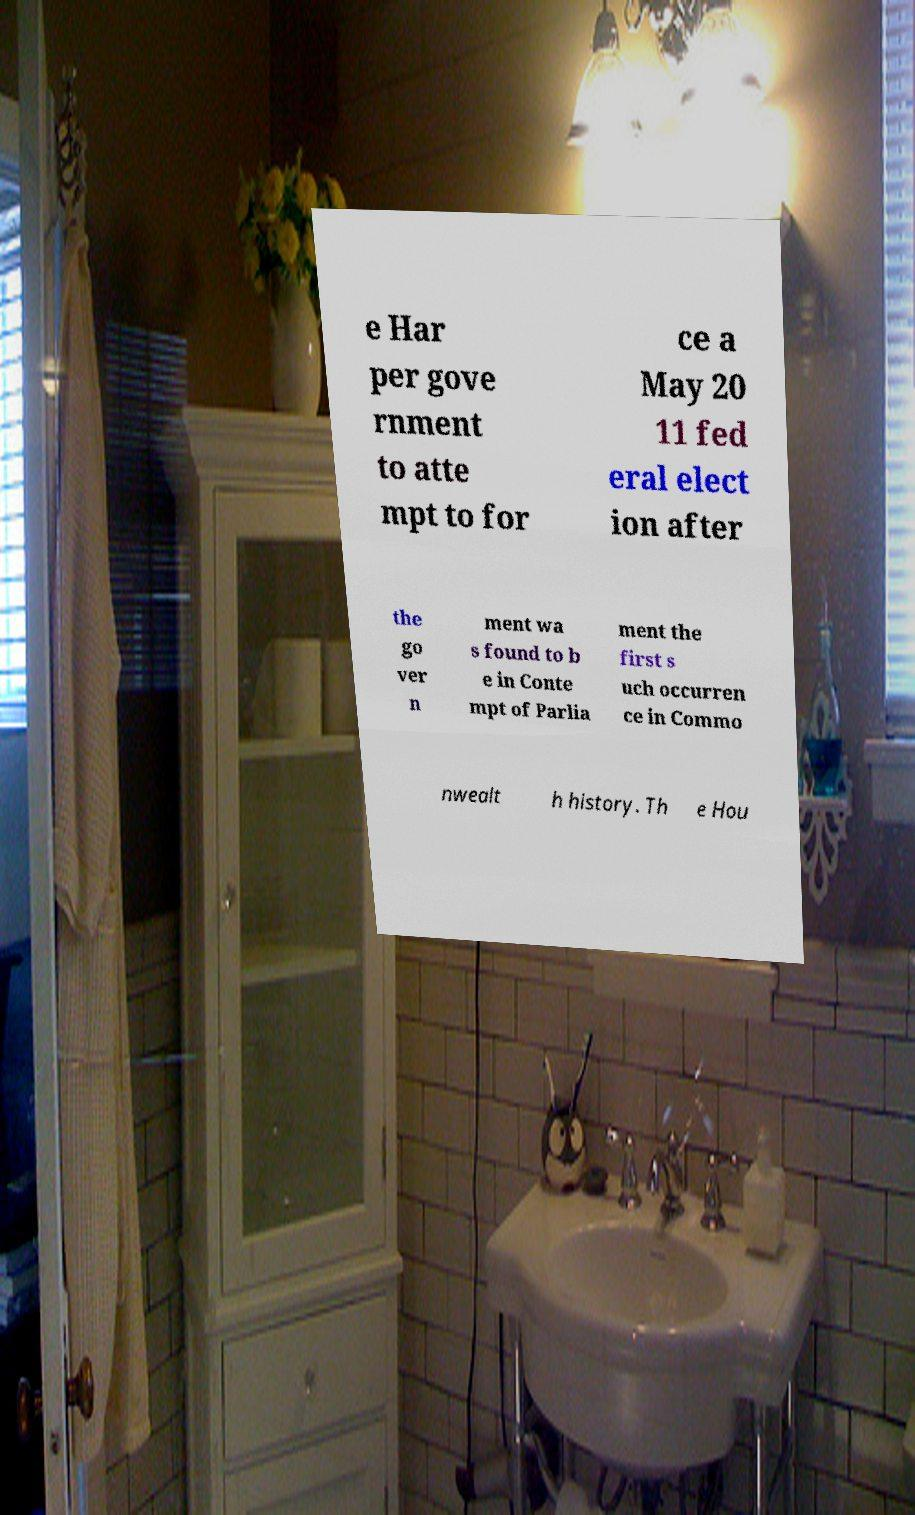There's text embedded in this image that I need extracted. Can you transcribe it verbatim? e Har per gove rnment to atte mpt to for ce a May 20 11 fed eral elect ion after the go ver n ment wa s found to b e in Conte mpt of Parlia ment the first s uch occurren ce in Commo nwealt h history. Th e Hou 